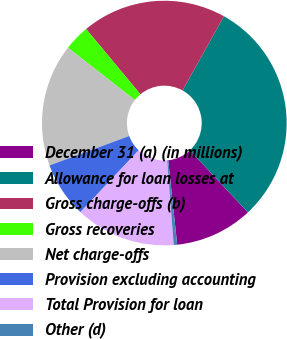Convert chart. <chart><loc_0><loc_0><loc_500><loc_500><pie_chart><fcel>December 31 (a) (in millions)<fcel>Allowance for loan losses at<fcel>Gross charge-offs (b)<fcel>Gross recoveries<fcel>Net charge-offs<fcel>Provision excluding accounting<fcel>Total Provision for loan<fcel>Other (d)<nl><fcel>10.3%<fcel>29.93%<fcel>19.14%<fcel>3.4%<fcel>16.19%<fcel>7.35%<fcel>13.25%<fcel>0.45%<nl></chart> 